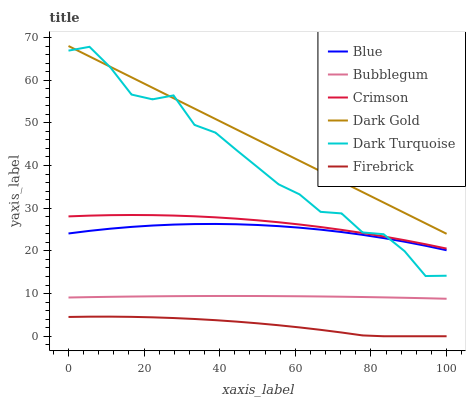Does Firebrick have the minimum area under the curve?
Answer yes or no. Yes. Does Dark Gold have the maximum area under the curve?
Answer yes or no. Yes. Does Dark Turquoise have the minimum area under the curve?
Answer yes or no. No. Does Dark Turquoise have the maximum area under the curve?
Answer yes or no. No. Is Dark Gold the smoothest?
Answer yes or no. Yes. Is Dark Turquoise the roughest?
Answer yes or no. Yes. Is Dark Turquoise the smoothest?
Answer yes or no. No. Is Dark Gold the roughest?
Answer yes or no. No. Does Firebrick have the lowest value?
Answer yes or no. Yes. Does Dark Turquoise have the lowest value?
Answer yes or no. No. Does Dark Gold have the highest value?
Answer yes or no. Yes. Does Dark Turquoise have the highest value?
Answer yes or no. No. Is Firebrick less than Dark Turquoise?
Answer yes or no. Yes. Is Dark Gold greater than Bubblegum?
Answer yes or no. Yes. Does Crimson intersect Dark Turquoise?
Answer yes or no. Yes. Is Crimson less than Dark Turquoise?
Answer yes or no. No. Is Crimson greater than Dark Turquoise?
Answer yes or no. No. Does Firebrick intersect Dark Turquoise?
Answer yes or no. No. 